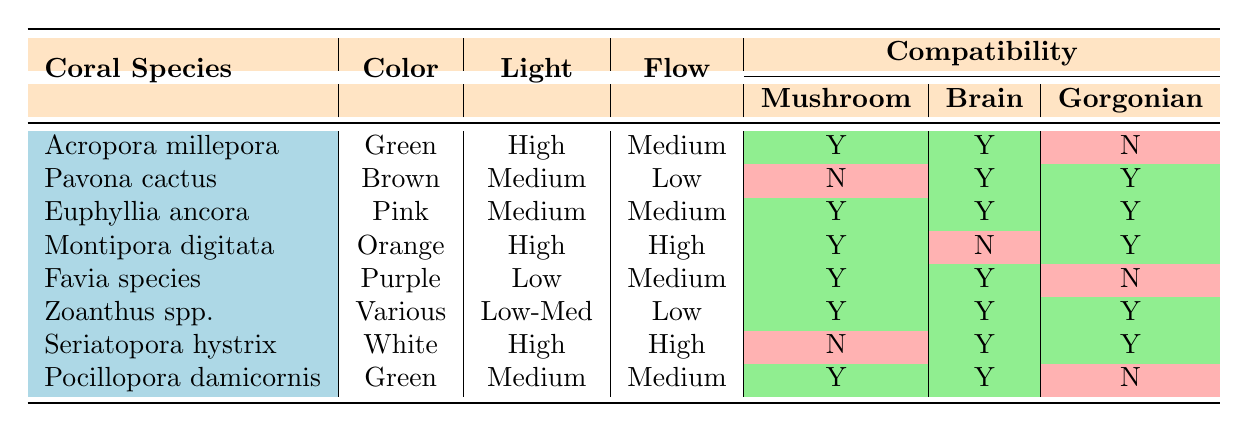What is the light need for Euphyllia ancora? The table shows a column for light needs, and Euphyllia ancora is listed under the "Coral Species" with a light need labeled as "Medium."
Answer: Medium Which coral species has a high water flow requirement but is incompatible with Mushroom Corals? Reviewing the table, Seriatopora hystrix is under the "Coral Species" column, marked with "High" for water flow and "Incompatible" for Mushroom Corals.
Answer: Seriatopora hystrix How many coral species are compatible with Xenia? To determine this, we count the species that have "Compatible" listed in the Xenia compatibility column: Euphyllia ancora, Montipora digitata, Favia species, Zoanthus spp., and Pavona cactus are all compatible. This gives us a total of five species.
Answer: 5 Is Acropora millepora compatible with Gorgonian? By checking the compatibility column for Gorgonian under Acropora millepora, it is marked as "Incompatible."
Answer: No Which coral species requires the highest light needs? The light needs column indicates that both Acropora millepora and Montipora digitata are marked as "High." Since they share this requirement, we identify both species as having the highest light needs.
Answer: Acropora millepora and Montipora digitata If you want to choose a compatible coral species with both Brain Coral and Xenia, which species could you select? We need to find coral species with "Compatible" listed for both Brain Coral and Xenia. Euphyllia ancora, Pavona cactus, and Favia species meet this criterion, as they have "Compatible" for both columns.
Answer: Euphyllia ancora, Pavona cactus, and Favia species Which coral species has the lowest light needs? Looking at the table, Favia species is categorized under "Low" in the light needs row, which is the lowest in comparison to the others.
Answer: Favia species Count the number of coral species with incompatible compatibility with both Mushroom Corals and Gorgonian. We review the compatibility for each species with both columns. Pavona cactus, Montipora digitata, and Pocillopora damicornis are incompatible with Mushroom Corals and Gorgonian, leading us to a total count of three species.
Answer: 3 